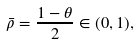<formula> <loc_0><loc_0><loc_500><loc_500>\bar { \rho } = \frac { 1 - \theta } { 2 } \in ( 0 , 1 ) ,</formula> 